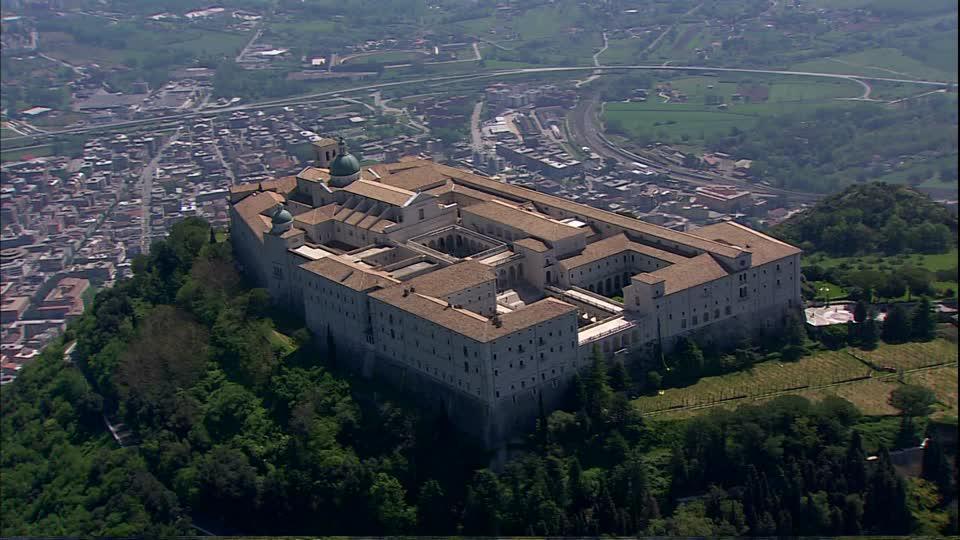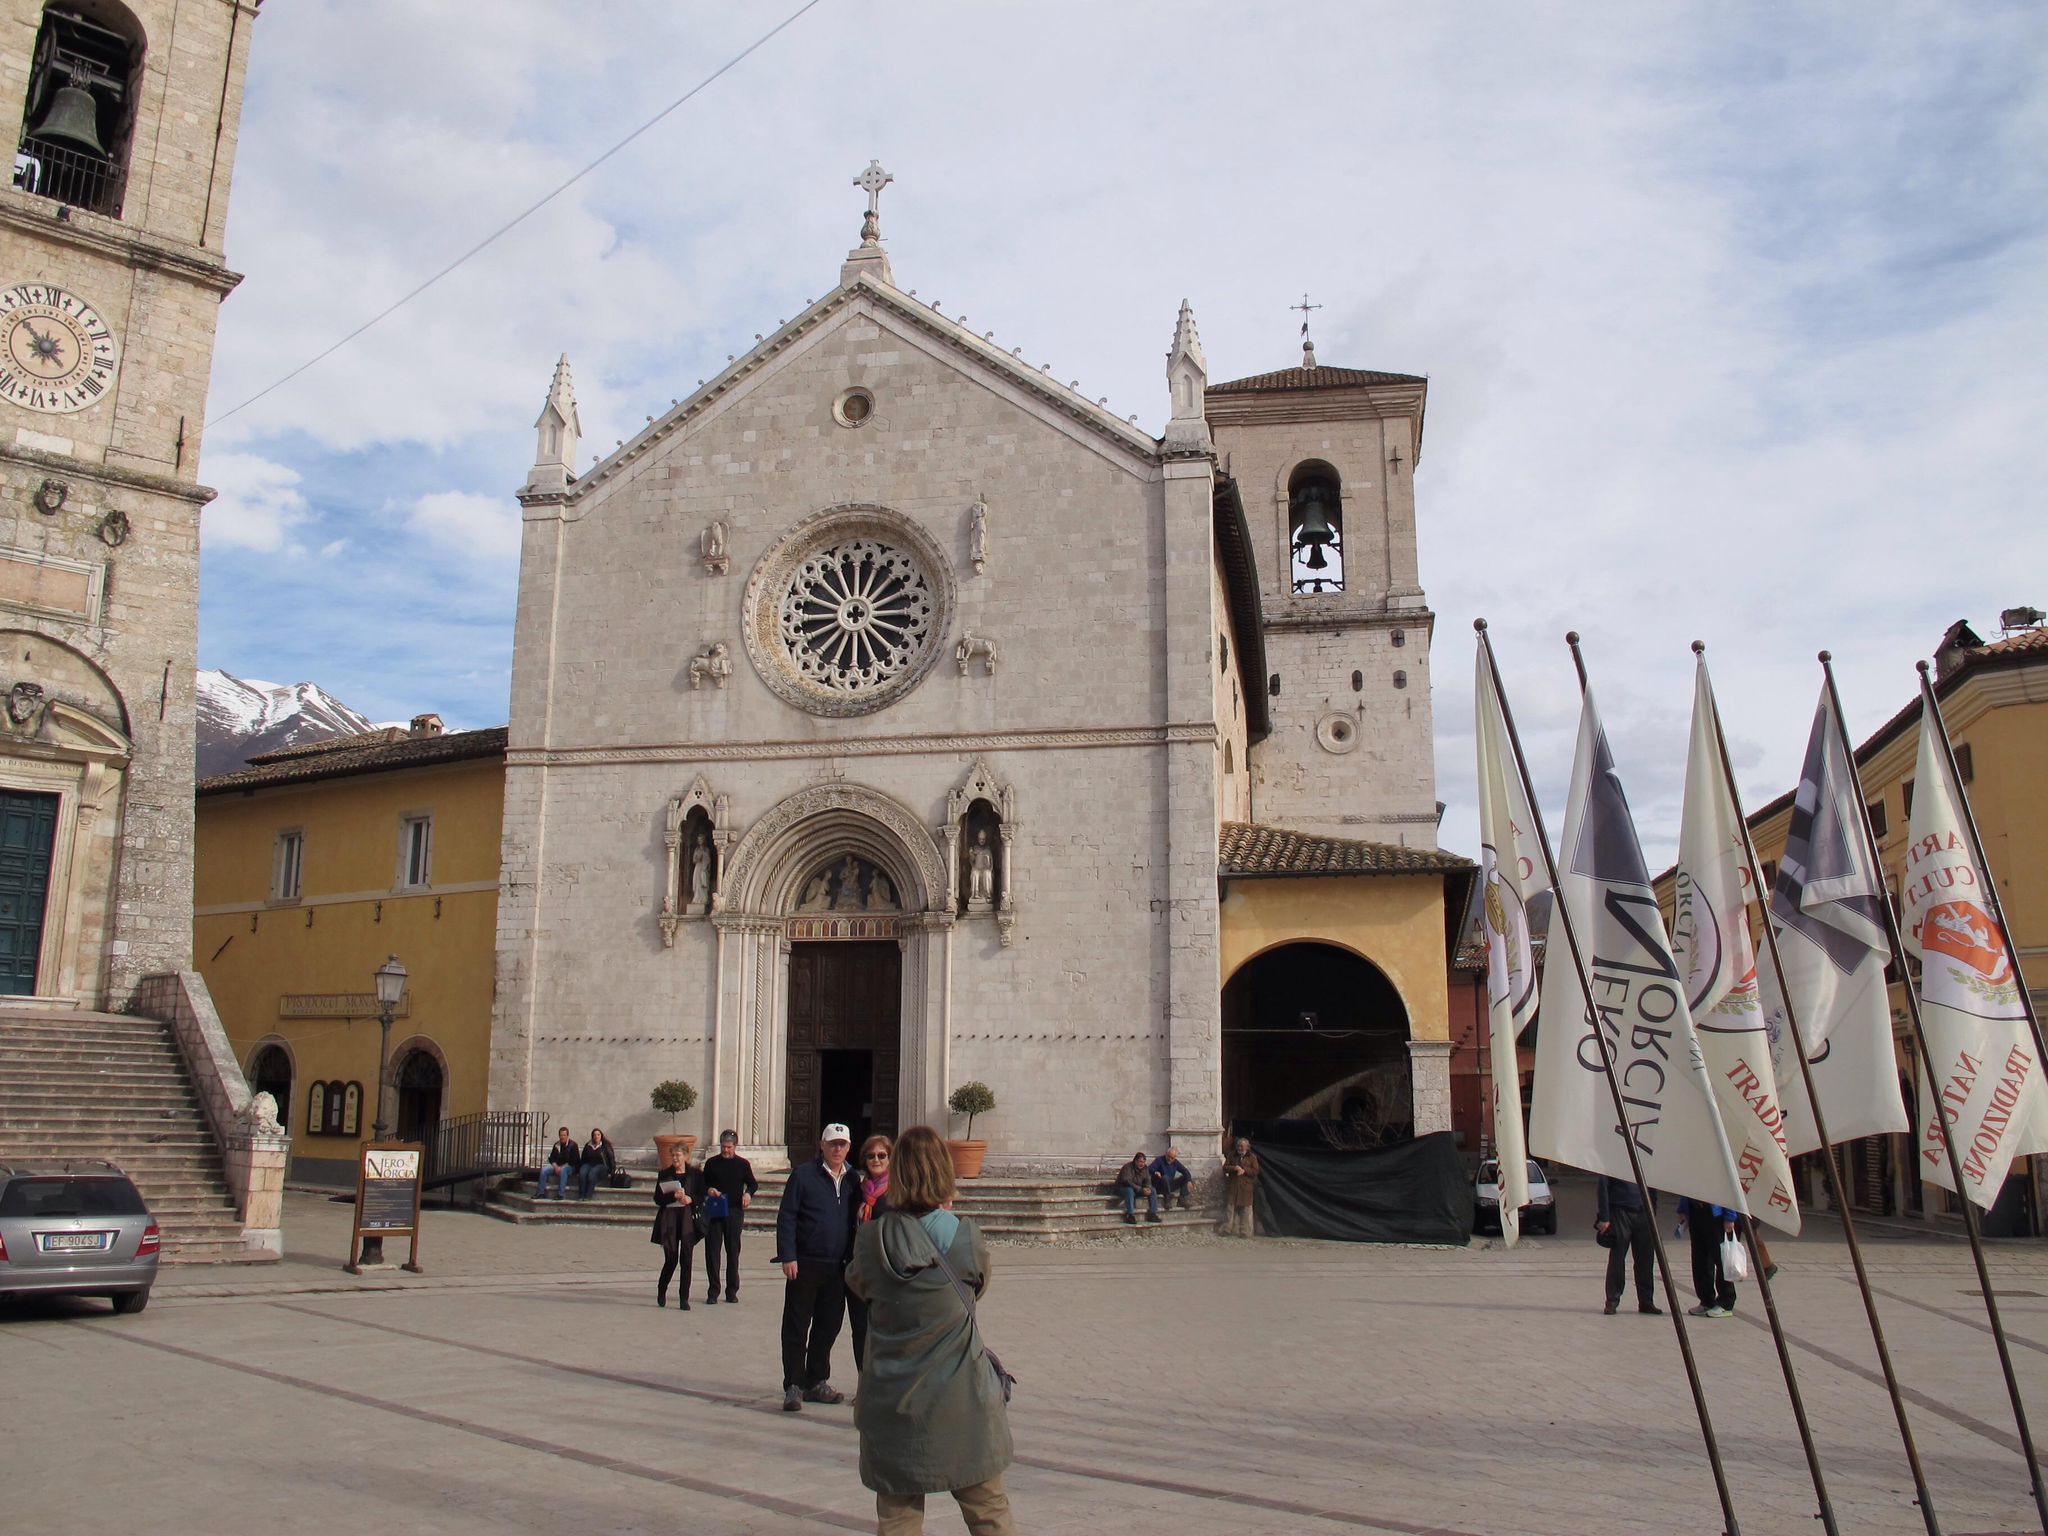The first image is the image on the left, the second image is the image on the right. For the images displayed, is the sentence "The building in the image on the left is surrounded by lush greenery." factually correct? Answer yes or no. Yes. The first image is the image on the left, the second image is the image on the right. Given the left and right images, does the statement "An image shows a stone-floored courtyard surrounded by arches, with a view through the arches into an empty distance." hold true? Answer yes or no. No. 